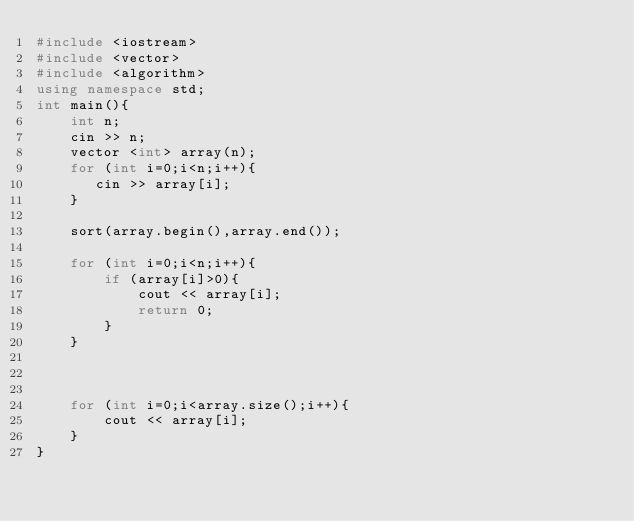<code> <loc_0><loc_0><loc_500><loc_500><_C++_>#include <iostream>
#include <vector>
#include <algorithm>
using namespace std;
int main(){
    int n;
    cin >> n;
    vector <int> array(n);
    for (int i=0;i<n;i++){
       cin >> array[i];
    }

    sort(array.begin(),array.end());

    for (int i=0;i<n;i++){
        if (array[i]>0){
            cout << array[i];
            return 0;
        }
    }



    for (int i=0;i<array.size();i++){
        cout << array[i];
    }    
}</code> 